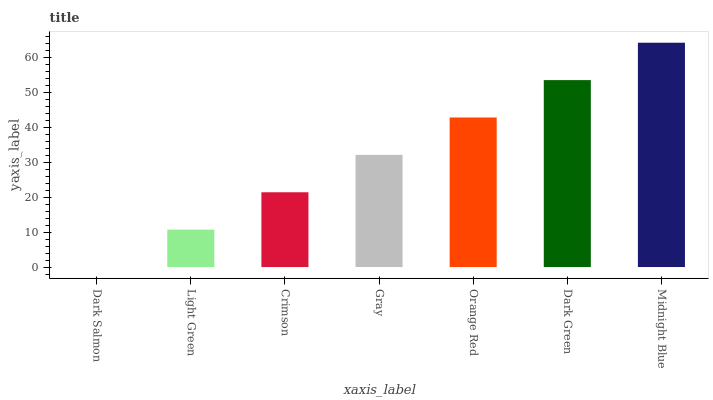Is Dark Salmon the minimum?
Answer yes or no. Yes. Is Midnight Blue the maximum?
Answer yes or no. Yes. Is Light Green the minimum?
Answer yes or no. No. Is Light Green the maximum?
Answer yes or no. No. Is Light Green greater than Dark Salmon?
Answer yes or no. Yes. Is Dark Salmon less than Light Green?
Answer yes or no. Yes. Is Dark Salmon greater than Light Green?
Answer yes or no. No. Is Light Green less than Dark Salmon?
Answer yes or no. No. Is Gray the high median?
Answer yes or no. Yes. Is Gray the low median?
Answer yes or no. Yes. Is Dark Salmon the high median?
Answer yes or no. No. Is Dark Salmon the low median?
Answer yes or no. No. 